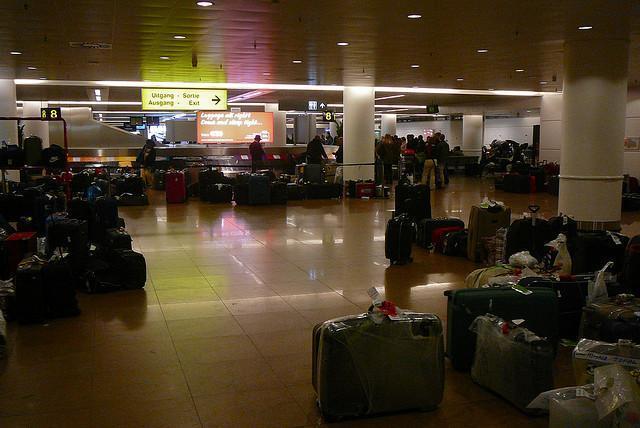How many suitcases are there?
Give a very brief answer. 5. How many rolls of toilet paper are in the photo?
Give a very brief answer. 0. 